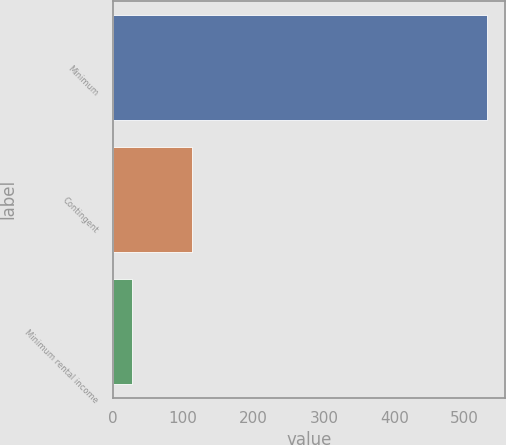Convert chart. <chart><loc_0><loc_0><loc_500><loc_500><bar_chart><fcel>Minimum<fcel>Contingent<fcel>Minimum rental income<nl><fcel>531<fcel>113<fcel>28<nl></chart> 